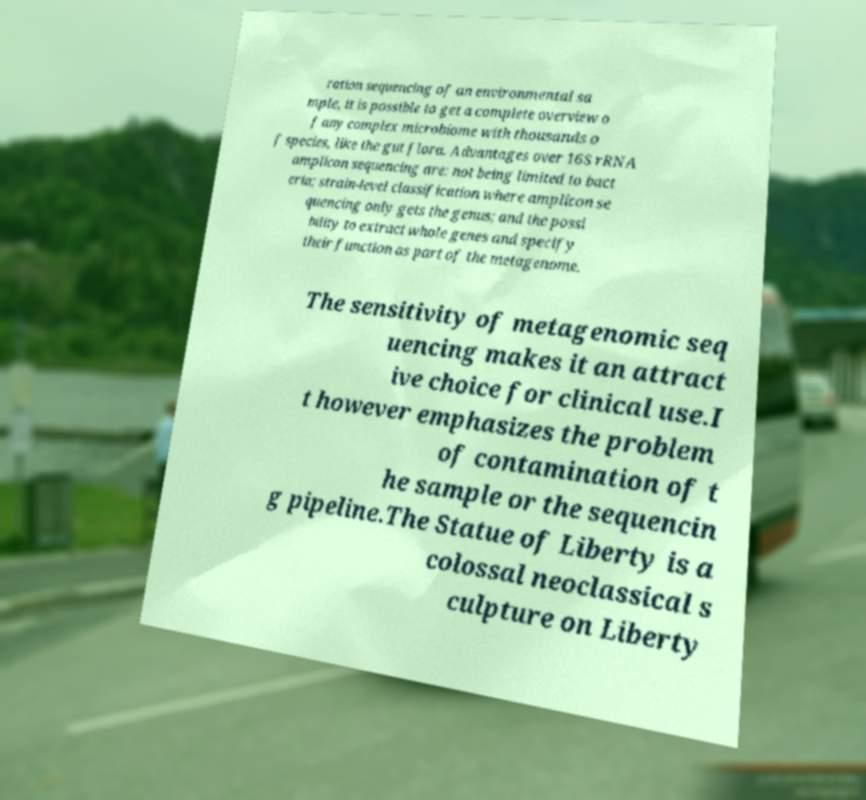Please identify and transcribe the text found in this image. ration sequencing of an environmental sa mple, it is possible to get a complete overview o f any complex microbiome with thousands o f species, like the gut flora. Advantages over 16S rRNA amplicon sequencing are: not being limited to bact eria; strain-level classification where amplicon se quencing only gets the genus; and the possi bility to extract whole genes and specify their function as part of the metagenome. The sensitivity of metagenomic seq uencing makes it an attract ive choice for clinical use.I t however emphasizes the problem of contamination of t he sample or the sequencin g pipeline.The Statue of Liberty is a colossal neoclassical s culpture on Liberty 